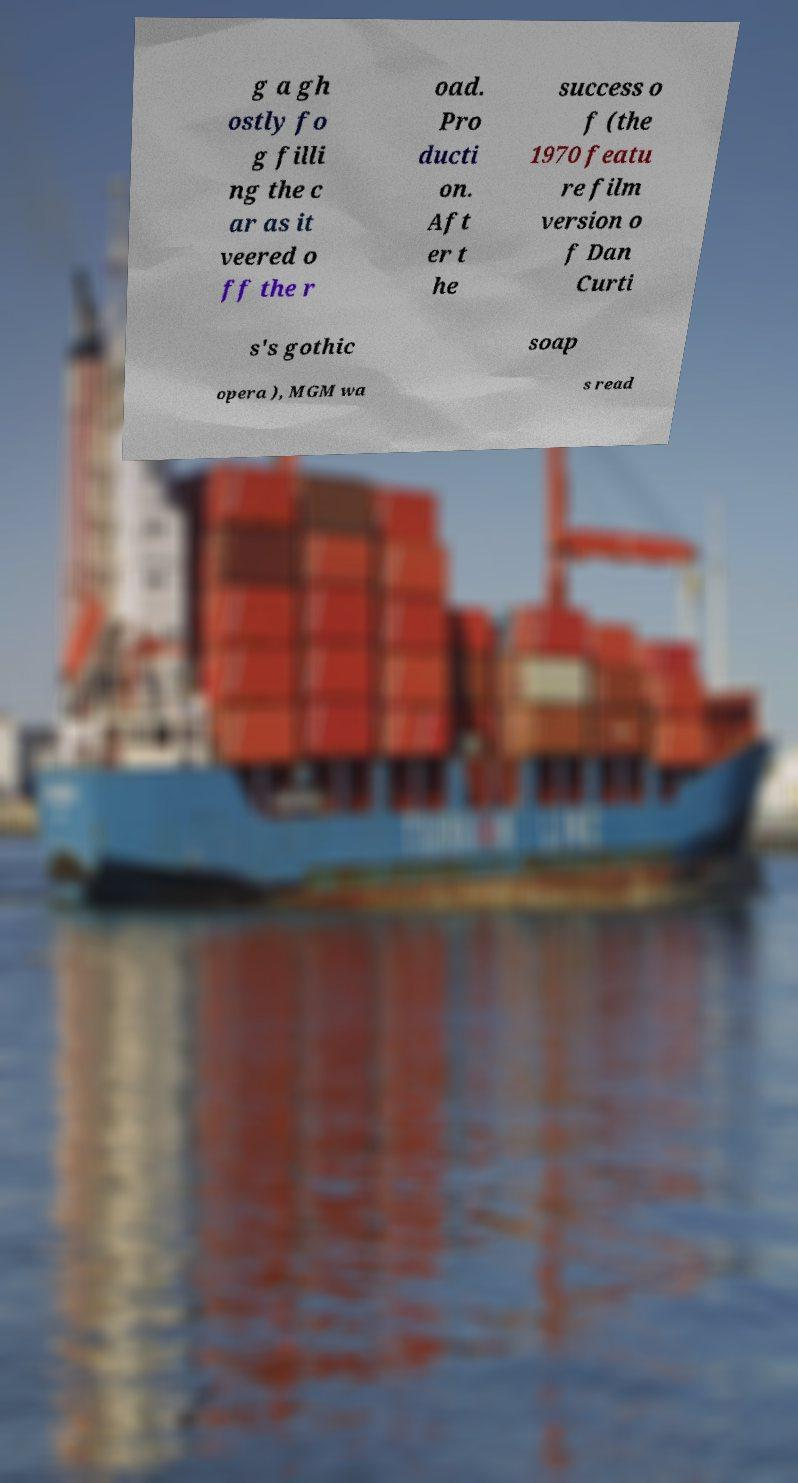For documentation purposes, I need the text within this image transcribed. Could you provide that? g a gh ostly fo g filli ng the c ar as it veered o ff the r oad. Pro ducti on. Aft er t he success o f (the 1970 featu re film version o f Dan Curti s's gothic soap opera ), MGM wa s read 